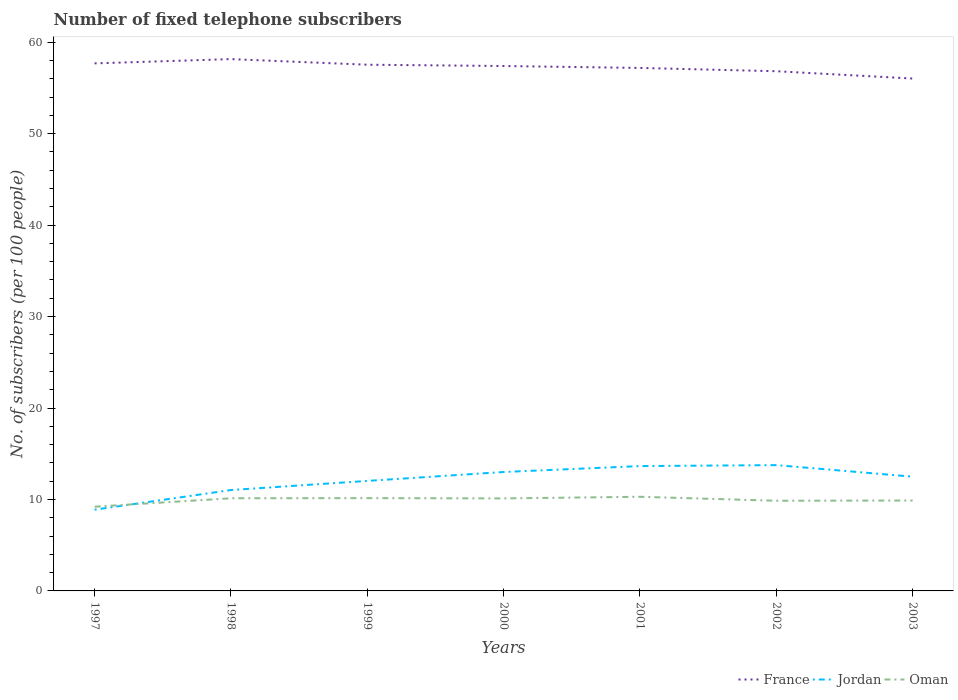Is the number of lines equal to the number of legend labels?
Make the answer very short. Yes. Across all years, what is the maximum number of fixed telephone subscribers in Oman?
Provide a succinct answer. 9.21. In which year was the number of fixed telephone subscribers in Oman maximum?
Give a very brief answer. 1997. What is the total number of fixed telephone subscribers in Jordan in the graph?
Provide a succinct answer. -0.11. What is the difference between the highest and the second highest number of fixed telephone subscribers in France?
Ensure brevity in your answer.  2.12. What is the difference between the highest and the lowest number of fixed telephone subscribers in Jordan?
Offer a very short reply. 4. Is the number of fixed telephone subscribers in France strictly greater than the number of fixed telephone subscribers in Oman over the years?
Provide a succinct answer. No. How many lines are there?
Provide a succinct answer. 3. How many years are there in the graph?
Your answer should be compact. 7. What is the difference between two consecutive major ticks on the Y-axis?
Your answer should be very brief. 10. Does the graph contain any zero values?
Your answer should be compact. No. Where does the legend appear in the graph?
Offer a very short reply. Bottom right. How are the legend labels stacked?
Offer a terse response. Horizontal. What is the title of the graph?
Your answer should be very brief. Number of fixed telephone subscribers. Does "Korea (Republic)" appear as one of the legend labels in the graph?
Provide a short and direct response. No. What is the label or title of the X-axis?
Keep it short and to the point. Years. What is the label or title of the Y-axis?
Keep it short and to the point. No. of subscribers (per 100 people). What is the No. of subscribers (per 100 people) of France in 1997?
Give a very brief answer. 57.69. What is the No. of subscribers (per 100 people) of Jordan in 1997?
Your answer should be compact. 8.88. What is the No. of subscribers (per 100 people) in Oman in 1997?
Keep it short and to the point. 9.21. What is the No. of subscribers (per 100 people) in France in 1998?
Keep it short and to the point. 58.15. What is the No. of subscribers (per 100 people) of Jordan in 1998?
Offer a terse response. 11.03. What is the No. of subscribers (per 100 people) of Oman in 1998?
Make the answer very short. 10.13. What is the No. of subscribers (per 100 people) in France in 1999?
Ensure brevity in your answer.  57.54. What is the No. of subscribers (per 100 people) in Jordan in 1999?
Your answer should be very brief. 12.03. What is the No. of subscribers (per 100 people) of Oman in 1999?
Make the answer very short. 10.14. What is the No. of subscribers (per 100 people) in France in 2000?
Your answer should be very brief. 57.4. What is the No. of subscribers (per 100 people) in Jordan in 2000?
Ensure brevity in your answer.  13. What is the No. of subscribers (per 100 people) of Oman in 2000?
Provide a short and direct response. 10.12. What is the No. of subscribers (per 100 people) of France in 2001?
Your answer should be compact. 57.19. What is the No. of subscribers (per 100 people) of Jordan in 2001?
Your response must be concise. 13.65. What is the No. of subscribers (per 100 people) in Oman in 2001?
Your response must be concise. 10.29. What is the No. of subscribers (per 100 people) of France in 2002?
Make the answer very short. 56.83. What is the No. of subscribers (per 100 people) of Jordan in 2002?
Your answer should be compact. 13.76. What is the No. of subscribers (per 100 people) in Oman in 2002?
Provide a succinct answer. 9.86. What is the No. of subscribers (per 100 people) in France in 2003?
Ensure brevity in your answer.  56.03. What is the No. of subscribers (per 100 people) of Jordan in 2003?
Your response must be concise. 12.49. What is the No. of subscribers (per 100 people) in Oman in 2003?
Ensure brevity in your answer.  9.89. Across all years, what is the maximum No. of subscribers (per 100 people) of France?
Your answer should be very brief. 58.15. Across all years, what is the maximum No. of subscribers (per 100 people) of Jordan?
Ensure brevity in your answer.  13.76. Across all years, what is the maximum No. of subscribers (per 100 people) of Oman?
Give a very brief answer. 10.29. Across all years, what is the minimum No. of subscribers (per 100 people) of France?
Offer a terse response. 56.03. Across all years, what is the minimum No. of subscribers (per 100 people) of Jordan?
Provide a short and direct response. 8.88. Across all years, what is the minimum No. of subscribers (per 100 people) of Oman?
Your answer should be compact. 9.21. What is the total No. of subscribers (per 100 people) in France in the graph?
Your response must be concise. 400.82. What is the total No. of subscribers (per 100 people) in Jordan in the graph?
Your answer should be very brief. 84.85. What is the total No. of subscribers (per 100 people) of Oman in the graph?
Ensure brevity in your answer.  69.64. What is the difference between the No. of subscribers (per 100 people) in France in 1997 and that in 1998?
Give a very brief answer. -0.47. What is the difference between the No. of subscribers (per 100 people) of Jordan in 1997 and that in 1998?
Give a very brief answer. -2.15. What is the difference between the No. of subscribers (per 100 people) in Oman in 1997 and that in 1998?
Provide a succinct answer. -0.92. What is the difference between the No. of subscribers (per 100 people) in France in 1997 and that in 1999?
Offer a terse response. 0.15. What is the difference between the No. of subscribers (per 100 people) of Jordan in 1997 and that in 1999?
Give a very brief answer. -3.15. What is the difference between the No. of subscribers (per 100 people) in Oman in 1997 and that in 1999?
Your response must be concise. -0.94. What is the difference between the No. of subscribers (per 100 people) in France in 1997 and that in 2000?
Give a very brief answer. 0.29. What is the difference between the No. of subscribers (per 100 people) in Jordan in 1997 and that in 2000?
Give a very brief answer. -4.12. What is the difference between the No. of subscribers (per 100 people) in Oman in 1997 and that in 2000?
Your response must be concise. -0.91. What is the difference between the No. of subscribers (per 100 people) in France in 1997 and that in 2001?
Provide a short and direct response. 0.5. What is the difference between the No. of subscribers (per 100 people) in Jordan in 1997 and that in 2001?
Provide a succinct answer. -4.77. What is the difference between the No. of subscribers (per 100 people) of Oman in 1997 and that in 2001?
Provide a short and direct response. -1.09. What is the difference between the No. of subscribers (per 100 people) in France in 1997 and that in 2002?
Keep it short and to the point. 0.86. What is the difference between the No. of subscribers (per 100 people) of Jordan in 1997 and that in 2002?
Ensure brevity in your answer.  -4.87. What is the difference between the No. of subscribers (per 100 people) of Oman in 1997 and that in 2002?
Your answer should be compact. -0.65. What is the difference between the No. of subscribers (per 100 people) of France in 1997 and that in 2003?
Make the answer very short. 1.66. What is the difference between the No. of subscribers (per 100 people) of Jordan in 1997 and that in 2003?
Your answer should be compact. -3.61. What is the difference between the No. of subscribers (per 100 people) of Oman in 1997 and that in 2003?
Make the answer very short. -0.68. What is the difference between the No. of subscribers (per 100 people) of France in 1998 and that in 1999?
Keep it short and to the point. 0.61. What is the difference between the No. of subscribers (per 100 people) of Jordan in 1998 and that in 1999?
Your answer should be very brief. -1. What is the difference between the No. of subscribers (per 100 people) in Oman in 1998 and that in 1999?
Your answer should be compact. -0.01. What is the difference between the No. of subscribers (per 100 people) of France in 1998 and that in 2000?
Your answer should be very brief. 0.76. What is the difference between the No. of subscribers (per 100 people) of Jordan in 1998 and that in 2000?
Make the answer very short. -1.97. What is the difference between the No. of subscribers (per 100 people) in Oman in 1998 and that in 2000?
Make the answer very short. 0.01. What is the difference between the No. of subscribers (per 100 people) of France in 1998 and that in 2001?
Provide a short and direct response. 0.97. What is the difference between the No. of subscribers (per 100 people) in Jordan in 1998 and that in 2001?
Provide a short and direct response. -2.62. What is the difference between the No. of subscribers (per 100 people) in Oman in 1998 and that in 2001?
Provide a short and direct response. -0.16. What is the difference between the No. of subscribers (per 100 people) of France in 1998 and that in 2002?
Your response must be concise. 1.33. What is the difference between the No. of subscribers (per 100 people) in Jordan in 1998 and that in 2002?
Your answer should be very brief. -2.73. What is the difference between the No. of subscribers (per 100 people) in Oman in 1998 and that in 2002?
Give a very brief answer. 0.27. What is the difference between the No. of subscribers (per 100 people) of France in 1998 and that in 2003?
Offer a very short reply. 2.12. What is the difference between the No. of subscribers (per 100 people) of Jordan in 1998 and that in 2003?
Your answer should be very brief. -1.46. What is the difference between the No. of subscribers (per 100 people) of Oman in 1998 and that in 2003?
Make the answer very short. 0.25. What is the difference between the No. of subscribers (per 100 people) of France in 1999 and that in 2000?
Your answer should be compact. 0.14. What is the difference between the No. of subscribers (per 100 people) in Jordan in 1999 and that in 2000?
Keep it short and to the point. -0.98. What is the difference between the No. of subscribers (per 100 people) in Oman in 1999 and that in 2000?
Provide a succinct answer. 0.03. What is the difference between the No. of subscribers (per 100 people) in France in 1999 and that in 2001?
Offer a terse response. 0.35. What is the difference between the No. of subscribers (per 100 people) in Jordan in 1999 and that in 2001?
Offer a very short reply. -1.62. What is the difference between the No. of subscribers (per 100 people) of Oman in 1999 and that in 2001?
Offer a very short reply. -0.15. What is the difference between the No. of subscribers (per 100 people) of France in 1999 and that in 2002?
Keep it short and to the point. 0.71. What is the difference between the No. of subscribers (per 100 people) of Jordan in 1999 and that in 2002?
Give a very brief answer. -1.73. What is the difference between the No. of subscribers (per 100 people) in Oman in 1999 and that in 2002?
Your answer should be very brief. 0.28. What is the difference between the No. of subscribers (per 100 people) of France in 1999 and that in 2003?
Keep it short and to the point. 1.51. What is the difference between the No. of subscribers (per 100 people) of Jordan in 1999 and that in 2003?
Offer a very short reply. -0.46. What is the difference between the No. of subscribers (per 100 people) in Oman in 1999 and that in 2003?
Provide a succinct answer. 0.26. What is the difference between the No. of subscribers (per 100 people) in France in 2000 and that in 2001?
Your response must be concise. 0.21. What is the difference between the No. of subscribers (per 100 people) in Jordan in 2000 and that in 2001?
Offer a terse response. -0.65. What is the difference between the No. of subscribers (per 100 people) of Oman in 2000 and that in 2001?
Your response must be concise. -0.18. What is the difference between the No. of subscribers (per 100 people) of France in 2000 and that in 2002?
Offer a terse response. 0.57. What is the difference between the No. of subscribers (per 100 people) in Jordan in 2000 and that in 2002?
Keep it short and to the point. -0.75. What is the difference between the No. of subscribers (per 100 people) in Oman in 2000 and that in 2002?
Your response must be concise. 0.26. What is the difference between the No. of subscribers (per 100 people) of France in 2000 and that in 2003?
Your response must be concise. 1.37. What is the difference between the No. of subscribers (per 100 people) of Jordan in 2000 and that in 2003?
Provide a short and direct response. 0.51. What is the difference between the No. of subscribers (per 100 people) in Oman in 2000 and that in 2003?
Keep it short and to the point. 0.23. What is the difference between the No. of subscribers (per 100 people) of France in 2001 and that in 2002?
Make the answer very short. 0.36. What is the difference between the No. of subscribers (per 100 people) in Jordan in 2001 and that in 2002?
Offer a very short reply. -0.11. What is the difference between the No. of subscribers (per 100 people) of Oman in 2001 and that in 2002?
Ensure brevity in your answer.  0.43. What is the difference between the No. of subscribers (per 100 people) of France in 2001 and that in 2003?
Your response must be concise. 1.16. What is the difference between the No. of subscribers (per 100 people) in Jordan in 2001 and that in 2003?
Provide a short and direct response. 1.16. What is the difference between the No. of subscribers (per 100 people) of Oman in 2001 and that in 2003?
Provide a short and direct response. 0.41. What is the difference between the No. of subscribers (per 100 people) in France in 2002 and that in 2003?
Offer a terse response. 0.8. What is the difference between the No. of subscribers (per 100 people) of Jordan in 2002 and that in 2003?
Make the answer very short. 1.26. What is the difference between the No. of subscribers (per 100 people) in Oman in 2002 and that in 2003?
Offer a terse response. -0.02. What is the difference between the No. of subscribers (per 100 people) of France in 1997 and the No. of subscribers (per 100 people) of Jordan in 1998?
Provide a succinct answer. 46.66. What is the difference between the No. of subscribers (per 100 people) in France in 1997 and the No. of subscribers (per 100 people) in Oman in 1998?
Keep it short and to the point. 47.56. What is the difference between the No. of subscribers (per 100 people) of Jordan in 1997 and the No. of subscribers (per 100 people) of Oman in 1998?
Offer a terse response. -1.25. What is the difference between the No. of subscribers (per 100 people) in France in 1997 and the No. of subscribers (per 100 people) in Jordan in 1999?
Offer a terse response. 45.66. What is the difference between the No. of subscribers (per 100 people) in France in 1997 and the No. of subscribers (per 100 people) in Oman in 1999?
Provide a short and direct response. 47.54. What is the difference between the No. of subscribers (per 100 people) of Jordan in 1997 and the No. of subscribers (per 100 people) of Oman in 1999?
Your answer should be compact. -1.26. What is the difference between the No. of subscribers (per 100 people) in France in 1997 and the No. of subscribers (per 100 people) in Jordan in 2000?
Provide a short and direct response. 44.68. What is the difference between the No. of subscribers (per 100 people) of France in 1997 and the No. of subscribers (per 100 people) of Oman in 2000?
Keep it short and to the point. 47.57. What is the difference between the No. of subscribers (per 100 people) of Jordan in 1997 and the No. of subscribers (per 100 people) of Oman in 2000?
Make the answer very short. -1.23. What is the difference between the No. of subscribers (per 100 people) in France in 1997 and the No. of subscribers (per 100 people) in Jordan in 2001?
Your answer should be very brief. 44.04. What is the difference between the No. of subscribers (per 100 people) of France in 1997 and the No. of subscribers (per 100 people) of Oman in 2001?
Your answer should be very brief. 47.39. What is the difference between the No. of subscribers (per 100 people) in Jordan in 1997 and the No. of subscribers (per 100 people) in Oman in 2001?
Provide a short and direct response. -1.41. What is the difference between the No. of subscribers (per 100 people) of France in 1997 and the No. of subscribers (per 100 people) of Jordan in 2002?
Give a very brief answer. 43.93. What is the difference between the No. of subscribers (per 100 people) in France in 1997 and the No. of subscribers (per 100 people) in Oman in 2002?
Your answer should be compact. 47.83. What is the difference between the No. of subscribers (per 100 people) in Jordan in 1997 and the No. of subscribers (per 100 people) in Oman in 2002?
Make the answer very short. -0.98. What is the difference between the No. of subscribers (per 100 people) of France in 1997 and the No. of subscribers (per 100 people) of Jordan in 2003?
Give a very brief answer. 45.19. What is the difference between the No. of subscribers (per 100 people) of France in 1997 and the No. of subscribers (per 100 people) of Oman in 2003?
Give a very brief answer. 47.8. What is the difference between the No. of subscribers (per 100 people) of Jordan in 1997 and the No. of subscribers (per 100 people) of Oman in 2003?
Offer a very short reply. -1. What is the difference between the No. of subscribers (per 100 people) of France in 1998 and the No. of subscribers (per 100 people) of Jordan in 1999?
Keep it short and to the point. 46.12. What is the difference between the No. of subscribers (per 100 people) of France in 1998 and the No. of subscribers (per 100 people) of Oman in 1999?
Keep it short and to the point. 48.01. What is the difference between the No. of subscribers (per 100 people) of Jordan in 1998 and the No. of subscribers (per 100 people) of Oman in 1999?
Your response must be concise. 0.89. What is the difference between the No. of subscribers (per 100 people) of France in 1998 and the No. of subscribers (per 100 people) of Jordan in 2000?
Provide a short and direct response. 45.15. What is the difference between the No. of subscribers (per 100 people) of France in 1998 and the No. of subscribers (per 100 people) of Oman in 2000?
Your response must be concise. 48.04. What is the difference between the No. of subscribers (per 100 people) in Jordan in 1998 and the No. of subscribers (per 100 people) in Oman in 2000?
Give a very brief answer. 0.92. What is the difference between the No. of subscribers (per 100 people) of France in 1998 and the No. of subscribers (per 100 people) of Jordan in 2001?
Your response must be concise. 44.5. What is the difference between the No. of subscribers (per 100 people) in France in 1998 and the No. of subscribers (per 100 people) in Oman in 2001?
Offer a terse response. 47.86. What is the difference between the No. of subscribers (per 100 people) of Jordan in 1998 and the No. of subscribers (per 100 people) of Oman in 2001?
Give a very brief answer. 0.74. What is the difference between the No. of subscribers (per 100 people) of France in 1998 and the No. of subscribers (per 100 people) of Jordan in 2002?
Ensure brevity in your answer.  44.4. What is the difference between the No. of subscribers (per 100 people) of France in 1998 and the No. of subscribers (per 100 people) of Oman in 2002?
Offer a terse response. 48.29. What is the difference between the No. of subscribers (per 100 people) in Jordan in 1998 and the No. of subscribers (per 100 people) in Oman in 2002?
Your answer should be compact. 1.17. What is the difference between the No. of subscribers (per 100 people) in France in 1998 and the No. of subscribers (per 100 people) in Jordan in 2003?
Your response must be concise. 45.66. What is the difference between the No. of subscribers (per 100 people) in France in 1998 and the No. of subscribers (per 100 people) in Oman in 2003?
Give a very brief answer. 48.27. What is the difference between the No. of subscribers (per 100 people) in Jordan in 1998 and the No. of subscribers (per 100 people) in Oman in 2003?
Offer a very short reply. 1.15. What is the difference between the No. of subscribers (per 100 people) of France in 1999 and the No. of subscribers (per 100 people) of Jordan in 2000?
Provide a short and direct response. 44.54. What is the difference between the No. of subscribers (per 100 people) in France in 1999 and the No. of subscribers (per 100 people) in Oman in 2000?
Your response must be concise. 47.42. What is the difference between the No. of subscribers (per 100 people) of Jordan in 1999 and the No. of subscribers (per 100 people) of Oman in 2000?
Keep it short and to the point. 1.91. What is the difference between the No. of subscribers (per 100 people) in France in 1999 and the No. of subscribers (per 100 people) in Jordan in 2001?
Keep it short and to the point. 43.89. What is the difference between the No. of subscribers (per 100 people) in France in 1999 and the No. of subscribers (per 100 people) in Oman in 2001?
Your answer should be very brief. 47.24. What is the difference between the No. of subscribers (per 100 people) in Jordan in 1999 and the No. of subscribers (per 100 people) in Oman in 2001?
Offer a terse response. 1.73. What is the difference between the No. of subscribers (per 100 people) in France in 1999 and the No. of subscribers (per 100 people) in Jordan in 2002?
Provide a succinct answer. 43.78. What is the difference between the No. of subscribers (per 100 people) of France in 1999 and the No. of subscribers (per 100 people) of Oman in 2002?
Ensure brevity in your answer.  47.68. What is the difference between the No. of subscribers (per 100 people) in Jordan in 1999 and the No. of subscribers (per 100 people) in Oman in 2002?
Provide a succinct answer. 2.17. What is the difference between the No. of subscribers (per 100 people) of France in 1999 and the No. of subscribers (per 100 people) of Jordan in 2003?
Ensure brevity in your answer.  45.05. What is the difference between the No. of subscribers (per 100 people) in France in 1999 and the No. of subscribers (per 100 people) in Oman in 2003?
Keep it short and to the point. 47.65. What is the difference between the No. of subscribers (per 100 people) in Jordan in 1999 and the No. of subscribers (per 100 people) in Oman in 2003?
Provide a succinct answer. 2.14. What is the difference between the No. of subscribers (per 100 people) in France in 2000 and the No. of subscribers (per 100 people) in Jordan in 2001?
Ensure brevity in your answer.  43.75. What is the difference between the No. of subscribers (per 100 people) in France in 2000 and the No. of subscribers (per 100 people) in Oman in 2001?
Your answer should be compact. 47.1. What is the difference between the No. of subscribers (per 100 people) of Jordan in 2000 and the No. of subscribers (per 100 people) of Oman in 2001?
Keep it short and to the point. 2.71. What is the difference between the No. of subscribers (per 100 people) of France in 2000 and the No. of subscribers (per 100 people) of Jordan in 2002?
Your response must be concise. 43.64. What is the difference between the No. of subscribers (per 100 people) in France in 2000 and the No. of subscribers (per 100 people) in Oman in 2002?
Ensure brevity in your answer.  47.54. What is the difference between the No. of subscribers (per 100 people) in Jordan in 2000 and the No. of subscribers (per 100 people) in Oman in 2002?
Offer a terse response. 3.14. What is the difference between the No. of subscribers (per 100 people) in France in 2000 and the No. of subscribers (per 100 people) in Jordan in 2003?
Provide a succinct answer. 44.91. What is the difference between the No. of subscribers (per 100 people) in France in 2000 and the No. of subscribers (per 100 people) in Oman in 2003?
Your answer should be very brief. 47.51. What is the difference between the No. of subscribers (per 100 people) in Jordan in 2000 and the No. of subscribers (per 100 people) in Oman in 2003?
Make the answer very short. 3.12. What is the difference between the No. of subscribers (per 100 people) in France in 2001 and the No. of subscribers (per 100 people) in Jordan in 2002?
Give a very brief answer. 43.43. What is the difference between the No. of subscribers (per 100 people) in France in 2001 and the No. of subscribers (per 100 people) in Oman in 2002?
Offer a very short reply. 47.33. What is the difference between the No. of subscribers (per 100 people) in Jordan in 2001 and the No. of subscribers (per 100 people) in Oman in 2002?
Ensure brevity in your answer.  3.79. What is the difference between the No. of subscribers (per 100 people) in France in 2001 and the No. of subscribers (per 100 people) in Jordan in 2003?
Your answer should be compact. 44.69. What is the difference between the No. of subscribers (per 100 people) of France in 2001 and the No. of subscribers (per 100 people) of Oman in 2003?
Ensure brevity in your answer.  47.3. What is the difference between the No. of subscribers (per 100 people) in Jordan in 2001 and the No. of subscribers (per 100 people) in Oman in 2003?
Keep it short and to the point. 3.76. What is the difference between the No. of subscribers (per 100 people) in France in 2002 and the No. of subscribers (per 100 people) in Jordan in 2003?
Keep it short and to the point. 44.34. What is the difference between the No. of subscribers (per 100 people) in France in 2002 and the No. of subscribers (per 100 people) in Oman in 2003?
Your response must be concise. 46.94. What is the difference between the No. of subscribers (per 100 people) of Jordan in 2002 and the No. of subscribers (per 100 people) of Oman in 2003?
Ensure brevity in your answer.  3.87. What is the average No. of subscribers (per 100 people) in France per year?
Your response must be concise. 57.26. What is the average No. of subscribers (per 100 people) of Jordan per year?
Provide a short and direct response. 12.12. What is the average No. of subscribers (per 100 people) of Oman per year?
Your answer should be compact. 9.95. In the year 1997, what is the difference between the No. of subscribers (per 100 people) in France and No. of subscribers (per 100 people) in Jordan?
Give a very brief answer. 48.8. In the year 1997, what is the difference between the No. of subscribers (per 100 people) in France and No. of subscribers (per 100 people) in Oman?
Offer a very short reply. 48.48. In the year 1997, what is the difference between the No. of subscribers (per 100 people) of Jordan and No. of subscribers (per 100 people) of Oman?
Ensure brevity in your answer.  -0.33. In the year 1998, what is the difference between the No. of subscribers (per 100 people) of France and No. of subscribers (per 100 people) of Jordan?
Provide a succinct answer. 47.12. In the year 1998, what is the difference between the No. of subscribers (per 100 people) of France and No. of subscribers (per 100 people) of Oman?
Keep it short and to the point. 48.02. In the year 1998, what is the difference between the No. of subscribers (per 100 people) of Jordan and No. of subscribers (per 100 people) of Oman?
Offer a very short reply. 0.9. In the year 1999, what is the difference between the No. of subscribers (per 100 people) of France and No. of subscribers (per 100 people) of Jordan?
Make the answer very short. 45.51. In the year 1999, what is the difference between the No. of subscribers (per 100 people) of France and No. of subscribers (per 100 people) of Oman?
Ensure brevity in your answer.  47.4. In the year 1999, what is the difference between the No. of subscribers (per 100 people) in Jordan and No. of subscribers (per 100 people) in Oman?
Give a very brief answer. 1.88. In the year 2000, what is the difference between the No. of subscribers (per 100 people) of France and No. of subscribers (per 100 people) of Jordan?
Provide a short and direct response. 44.39. In the year 2000, what is the difference between the No. of subscribers (per 100 people) of France and No. of subscribers (per 100 people) of Oman?
Ensure brevity in your answer.  47.28. In the year 2000, what is the difference between the No. of subscribers (per 100 people) in Jordan and No. of subscribers (per 100 people) in Oman?
Your answer should be very brief. 2.89. In the year 2001, what is the difference between the No. of subscribers (per 100 people) in France and No. of subscribers (per 100 people) in Jordan?
Provide a short and direct response. 43.54. In the year 2001, what is the difference between the No. of subscribers (per 100 people) in France and No. of subscribers (per 100 people) in Oman?
Your response must be concise. 46.89. In the year 2001, what is the difference between the No. of subscribers (per 100 people) of Jordan and No. of subscribers (per 100 people) of Oman?
Your answer should be compact. 3.36. In the year 2002, what is the difference between the No. of subscribers (per 100 people) in France and No. of subscribers (per 100 people) in Jordan?
Provide a succinct answer. 43.07. In the year 2002, what is the difference between the No. of subscribers (per 100 people) in France and No. of subscribers (per 100 people) in Oman?
Provide a short and direct response. 46.97. In the year 2002, what is the difference between the No. of subscribers (per 100 people) of Jordan and No. of subscribers (per 100 people) of Oman?
Offer a very short reply. 3.9. In the year 2003, what is the difference between the No. of subscribers (per 100 people) of France and No. of subscribers (per 100 people) of Jordan?
Your response must be concise. 43.54. In the year 2003, what is the difference between the No. of subscribers (per 100 people) in France and No. of subscribers (per 100 people) in Oman?
Offer a terse response. 46.14. In the year 2003, what is the difference between the No. of subscribers (per 100 people) in Jordan and No. of subscribers (per 100 people) in Oman?
Make the answer very short. 2.61. What is the ratio of the No. of subscribers (per 100 people) in Jordan in 1997 to that in 1998?
Provide a succinct answer. 0.81. What is the ratio of the No. of subscribers (per 100 people) of Oman in 1997 to that in 1998?
Give a very brief answer. 0.91. What is the ratio of the No. of subscribers (per 100 people) in Jordan in 1997 to that in 1999?
Your answer should be very brief. 0.74. What is the ratio of the No. of subscribers (per 100 people) in Oman in 1997 to that in 1999?
Ensure brevity in your answer.  0.91. What is the ratio of the No. of subscribers (per 100 people) in Jordan in 1997 to that in 2000?
Provide a succinct answer. 0.68. What is the ratio of the No. of subscribers (per 100 people) in Oman in 1997 to that in 2000?
Make the answer very short. 0.91. What is the ratio of the No. of subscribers (per 100 people) of France in 1997 to that in 2001?
Ensure brevity in your answer.  1.01. What is the ratio of the No. of subscribers (per 100 people) in Jordan in 1997 to that in 2001?
Provide a succinct answer. 0.65. What is the ratio of the No. of subscribers (per 100 people) in Oman in 1997 to that in 2001?
Give a very brief answer. 0.89. What is the ratio of the No. of subscribers (per 100 people) in France in 1997 to that in 2002?
Offer a terse response. 1.02. What is the ratio of the No. of subscribers (per 100 people) of Jordan in 1997 to that in 2002?
Your response must be concise. 0.65. What is the ratio of the No. of subscribers (per 100 people) in Oman in 1997 to that in 2002?
Your answer should be very brief. 0.93. What is the ratio of the No. of subscribers (per 100 people) of France in 1997 to that in 2003?
Offer a terse response. 1.03. What is the ratio of the No. of subscribers (per 100 people) of Jordan in 1997 to that in 2003?
Provide a short and direct response. 0.71. What is the ratio of the No. of subscribers (per 100 people) in Oman in 1997 to that in 2003?
Offer a terse response. 0.93. What is the ratio of the No. of subscribers (per 100 people) of France in 1998 to that in 1999?
Offer a very short reply. 1.01. What is the ratio of the No. of subscribers (per 100 people) in Jordan in 1998 to that in 1999?
Give a very brief answer. 0.92. What is the ratio of the No. of subscribers (per 100 people) of France in 1998 to that in 2000?
Your response must be concise. 1.01. What is the ratio of the No. of subscribers (per 100 people) in Jordan in 1998 to that in 2000?
Ensure brevity in your answer.  0.85. What is the ratio of the No. of subscribers (per 100 people) of France in 1998 to that in 2001?
Give a very brief answer. 1.02. What is the ratio of the No. of subscribers (per 100 people) of Jordan in 1998 to that in 2001?
Give a very brief answer. 0.81. What is the ratio of the No. of subscribers (per 100 people) of Oman in 1998 to that in 2001?
Keep it short and to the point. 0.98. What is the ratio of the No. of subscribers (per 100 people) of France in 1998 to that in 2002?
Your answer should be compact. 1.02. What is the ratio of the No. of subscribers (per 100 people) of Jordan in 1998 to that in 2002?
Offer a terse response. 0.8. What is the ratio of the No. of subscribers (per 100 people) in Oman in 1998 to that in 2002?
Provide a short and direct response. 1.03. What is the ratio of the No. of subscribers (per 100 people) of France in 1998 to that in 2003?
Offer a very short reply. 1.04. What is the ratio of the No. of subscribers (per 100 people) in Jordan in 1998 to that in 2003?
Your answer should be very brief. 0.88. What is the ratio of the No. of subscribers (per 100 people) of Oman in 1998 to that in 2003?
Make the answer very short. 1.02. What is the ratio of the No. of subscribers (per 100 people) of Jordan in 1999 to that in 2000?
Offer a terse response. 0.93. What is the ratio of the No. of subscribers (per 100 people) in Jordan in 1999 to that in 2001?
Your answer should be compact. 0.88. What is the ratio of the No. of subscribers (per 100 people) in Oman in 1999 to that in 2001?
Provide a succinct answer. 0.99. What is the ratio of the No. of subscribers (per 100 people) in France in 1999 to that in 2002?
Offer a very short reply. 1.01. What is the ratio of the No. of subscribers (per 100 people) of Jordan in 1999 to that in 2002?
Make the answer very short. 0.87. What is the ratio of the No. of subscribers (per 100 people) in Oman in 1999 to that in 2002?
Make the answer very short. 1.03. What is the ratio of the No. of subscribers (per 100 people) of France in 1999 to that in 2003?
Provide a succinct answer. 1.03. What is the ratio of the No. of subscribers (per 100 people) in Jordan in 1999 to that in 2003?
Offer a terse response. 0.96. What is the ratio of the No. of subscribers (per 100 people) in Oman in 1999 to that in 2003?
Your answer should be very brief. 1.03. What is the ratio of the No. of subscribers (per 100 people) in France in 2000 to that in 2001?
Keep it short and to the point. 1. What is the ratio of the No. of subscribers (per 100 people) in Jordan in 2000 to that in 2001?
Offer a terse response. 0.95. What is the ratio of the No. of subscribers (per 100 people) in Oman in 2000 to that in 2001?
Provide a short and direct response. 0.98. What is the ratio of the No. of subscribers (per 100 people) in Jordan in 2000 to that in 2002?
Provide a short and direct response. 0.95. What is the ratio of the No. of subscribers (per 100 people) of Oman in 2000 to that in 2002?
Your answer should be very brief. 1.03. What is the ratio of the No. of subscribers (per 100 people) in France in 2000 to that in 2003?
Keep it short and to the point. 1.02. What is the ratio of the No. of subscribers (per 100 people) in Jordan in 2000 to that in 2003?
Your answer should be compact. 1.04. What is the ratio of the No. of subscribers (per 100 people) in Oman in 2000 to that in 2003?
Ensure brevity in your answer.  1.02. What is the ratio of the No. of subscribers (per 100 people) of Jordan in 2001 to that in 2002?
Your answer should be compact. 0.99. What is the ratio of the No. of subscribers (per 100 people) of Oman in 2001 to that in 2002?
Keep it short and to the point. 1.04. What is the ratio of the No. of subscribers (per 100 people) in France in 2001 to that in 2003?
Ensure brevity in your answer.  1.02. What is the ratio of the No. of subscribers (per 100 people) of Jordan in 2001 to that in 2003?
Your answer should be very brief. 1.09. What is the ratio of the No. of subscribers (per 100 people) of Oman in 2001 to that in 2003?
Give a very brief answer. 1.04. What is the ratio of the No. of subscribers (per 100 people) of France in 2002 to that in 2003?
Your answer should be very brief. 1.01. What is the ratio of the No. of subscribers (per 100 people) in Jordan in 2002 to that in 2003?
Your answer should be very brief. 1.1. What is the difference between the highest and the second highest No. of subscribers (per 100 people) in France?
Your answer should be compact. 0.47. What is the difference between the highest and the second highest No. of subscribers (per 100 people) in Jordan?
Give a very brief answer. 0.11. What is the difference between the highest and the second highest No. of subscribers (per 100 people) in Oman?
Your response must be concise. 0.15. What is the difference between the highest and the lowest No. of subscribers (per 100 people) in France?
Offer a terse response. 2.12. What is the difference between the highest and the lowest No. of subscribers (per 100 people) of Jordan?
Give a very brief answer. 4.87. What is the difference between the highest and the lowest No. of subscribers (per 100 people) in Oman?
Offer a very short reply. 1.09. 